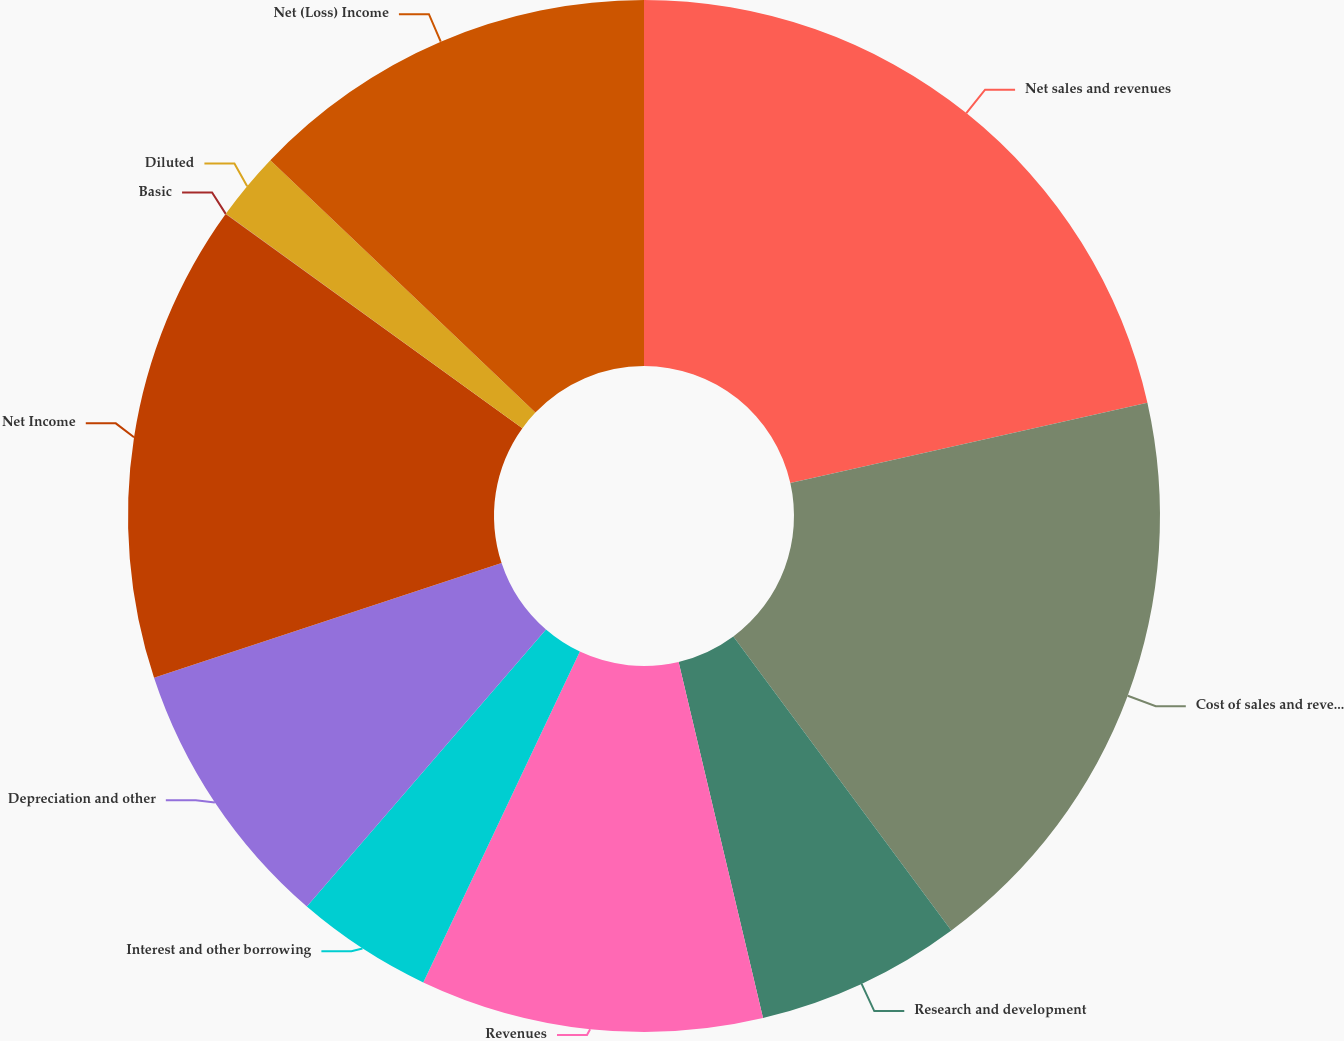Convert chart to OTSL. <chart><loc_0><loc_0><loc_500><loc_500><pie_chart><fcel>Net sales and revenues<fcel>Cost of sales and revenues<fcel>Research and development<fcel>Revenues<fcel>Interest and other borrowing<fcel>Depreciation and other<fcel>Net Income<fcel>Basic<fcel>Diluted<fcel>Net (Loss) Income<nl><fcel>21.48%<fcel>18.37%<fcel>6.45%<fcel>10.74%<fcel>4.3%<fcel>8.59%<fcel>15.03%<fcel>0.01%<fcel>2.15%<fcel>12.89%<nl></chart> 